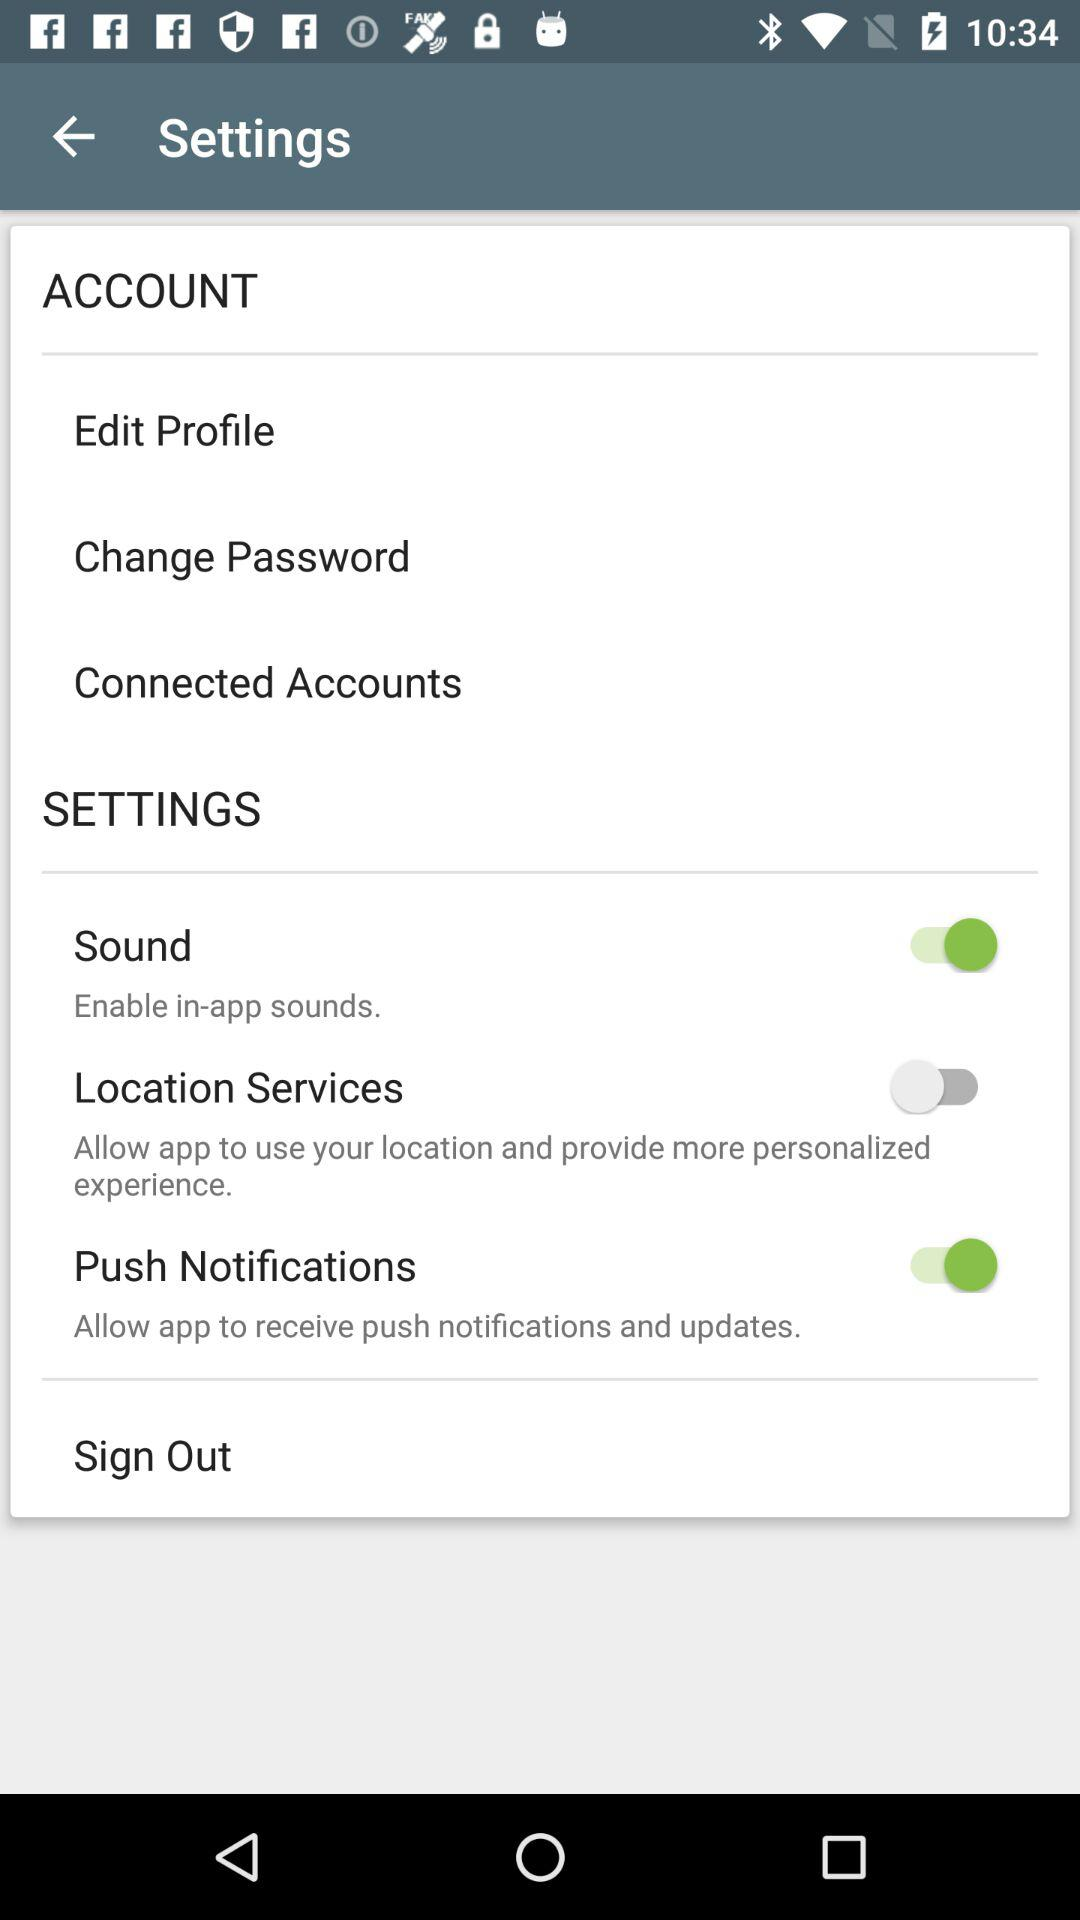What is the status of the sound? The status is "on". 